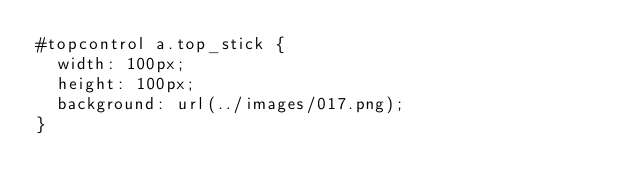<code> <loc_0><loc_0><loc_500><loc_500><_CSS_>#topcontrol a.top_stick {
	width: 100px;
	height: 100px;
	background: url(../images/017.png);
}</code> 